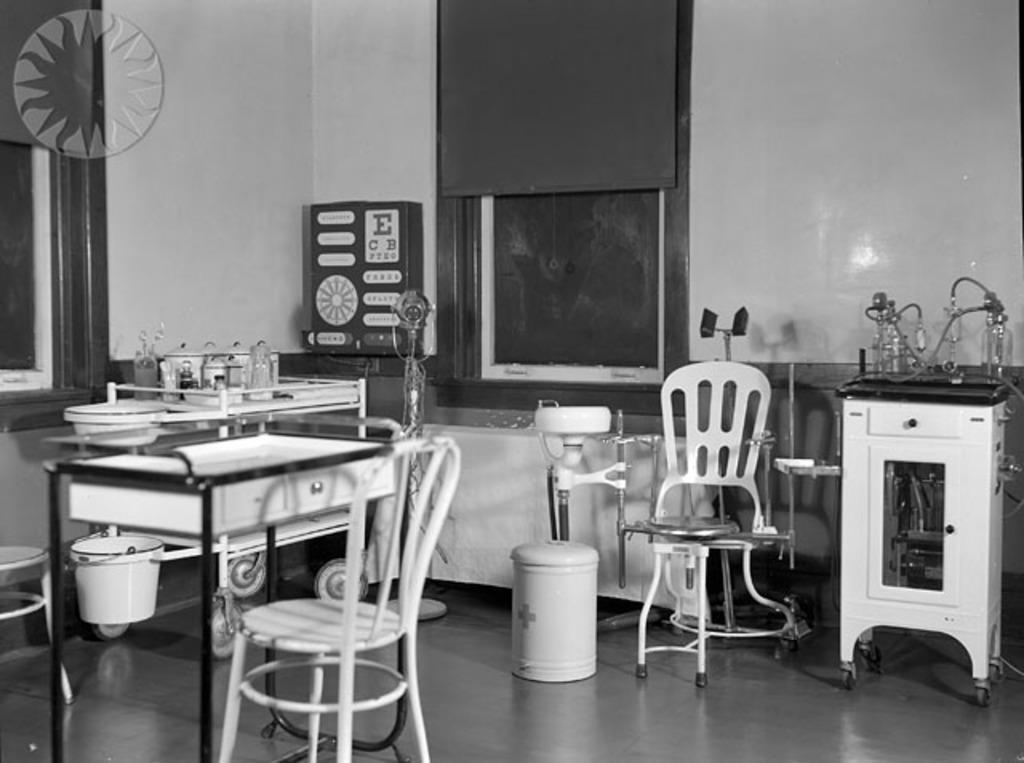Can you describe this image briefly? In this image we can see some trolleys, tables, stands, dustbin, bucket, and some hospital equipment, also we can see a wall, and windows. 